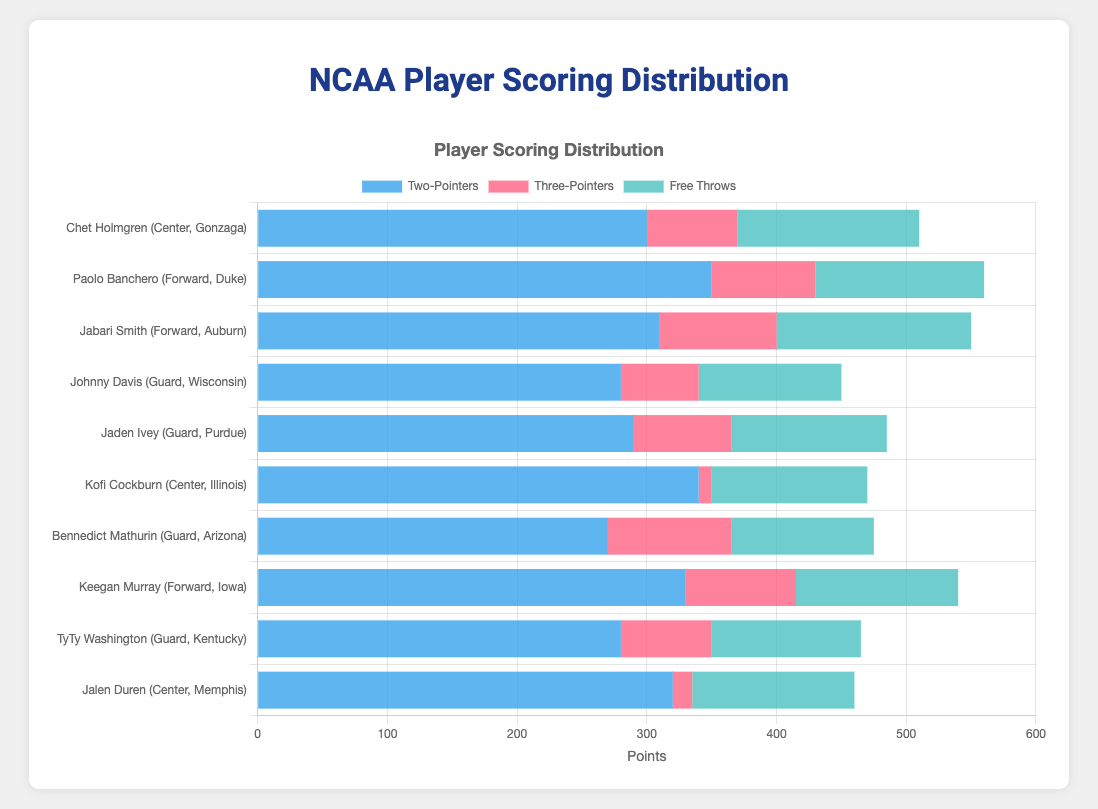Which player scored the most points from two-pointers? The bar representing two-pointers for each player shows that Paolo Banchero (Forward, Duke) has the tallest bar.
Answer: Paolo Banchero Who has a higher total number of points from three-pointers, Bennedict Mathurin or Keegan Murray? Bennedict Mathurin scored 95 points from three-pointers, whereas Keegan Murray scored 85 points.
Answer: Bennedict Mathurin Among guards, which player has the highest total points from free throws? Comparing the bars for free throws among guards, Johnny Davis has 110, Jaden Ivey has 120, Bennedict Mathurin has 110, and TyTy Washington has 115. Jaden Ivey has the highest.
Answer: Jaden Ivey Who scored more from three-pointers, Jabari Smith or Chet Holmgren? Jabari Smith scored 90 points from three-pointers, while Chet Holmgren scored 70 points.
Answer: Jabari Smith Compare the total points from two-pointers and free throws for Kofi Cockburn and Jalen Duren. Who has more combined points? Kofi Cockburn scored 340 from two-pointers and 120 from free throws (total 460). Jalen Duren scored 320 from two-pointers and 125 from free throws (total 445).
Answer: Kofi Cockburn Which player has the smallest contribution from three-pointers? The smallest three-pointer bar is for Kofi Cockburn (Center, Illinois) who has only 10 points from three-pointers.
Answer: Kofi Cockburn What is the total sum of points from free throws for all players? Adding the free throw points: 140 + 130 + 150 + 110 + 120 + 120 + 110 + 125 + 115 + 125 = 1245.
Answer: 1245 Which position has the highest average three-pointers? Calculate the average for each position:
- Guards: (60 + 75 + 95 + 70) / 4 = 75
- Forwards: (80 + 90 + 85) / 3 = 85
- Centers: (70 + 10 + 15) / 3 = 31.67
The average three-pointers are highest for Forwards.
Answer: Forwards Who has the highest total points combining two-pointers, three-pointers, and free throws? Calculate the total points for each player:
- Chet Holmgren: 300 + 70 + 140 = 510
- Paolo Banchero: 350 + 80 + 130 = 560
- Jabari Smith: 310 + 90 + 150 = 550
- Johnny Davis: 280 + 60 + 110 = 450
- Jaden Ivey: 290 + 75 + 120 = 485
- Kofi Cockburn: 340 + 10 + 120 = 470
- Bennedict Mathurin: 270 + 95 + 110 = 475
- Keegan Murray: 330 + 85 + 125 = 540
- TyTy Washington: 280 + 70 + 115 = 465
- Jalen Duren: 320 + 15 + 125 = 460
Paolo Banchero has the highest total points.
Answer: Paolo Banchero What is the distribution of free throws among all players? To understand the distribution, observe the free throw bars: Each player has varying lengths. The values range from 110 to 150 with Jabari Smith having the highest bar for free throws (150 points).
Answer: 110 to 150 points 